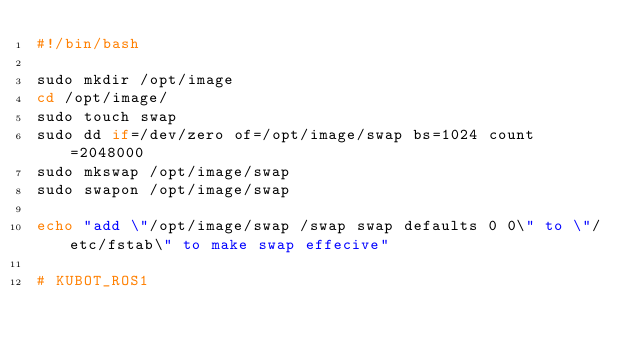Convert code to text. <code><loc_0><loc_0><loc_500><loc_500><_Bash_>#!/bin/bash

sudo mkdir /opt/image
cd /opt/image/
sudo touch swap
sudo dd if=/dev/zero of=/opt/image/swap bs=1024 count=2048000
sudo mkswap /opt/image/swap
sudo swapon /opt/image/swap

echo "add \"/opt/image/swap /swap swap defaults 0 0\" to \"/etc/fstab\" to make swap effecive"

# KUBOT_ROS1
</code> 